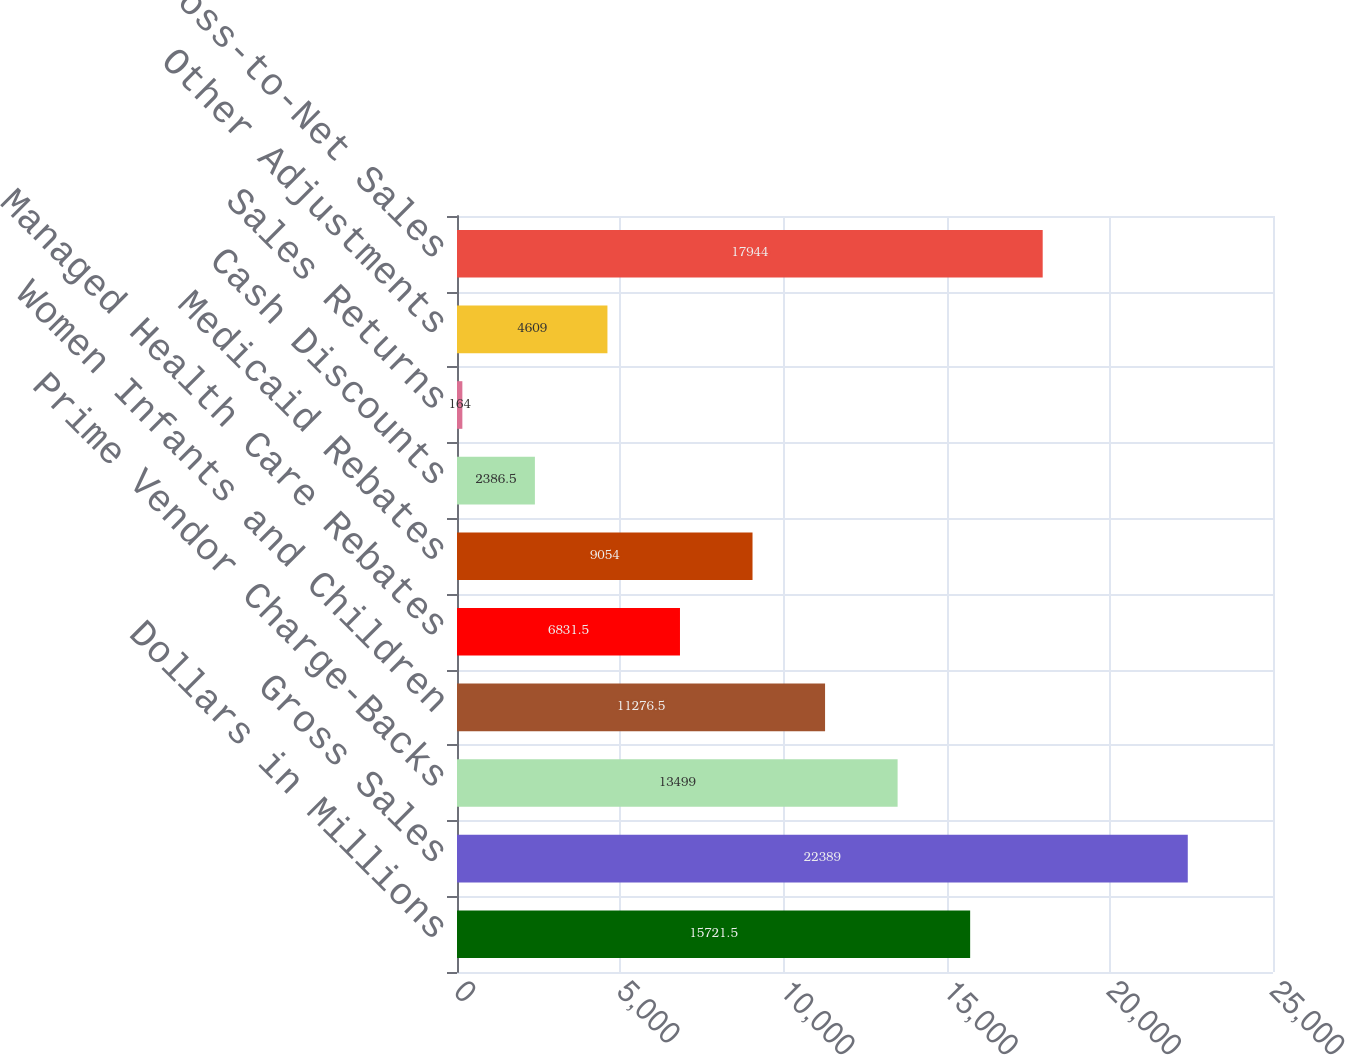Convert chart. <chart><loc_0><loc_0><loc_500><loc_500><bar_chart><fcel>Dollars in Millions<fcel>Gross Sales<fcel>Prime Vendor Charge-Backs<fcel>Women Infants and Children<fcel>Managed Health Care Rebates<fcel>Medicaid Rebates<fcel>Cash Discounts<fcel>Sales Returns<fcel>Other Adjustments<fcel>Total Gross-to-Net Sales<nl><fcel>15721.5<fcel>22389<fcel>13499<fcel>11276.5<fcel>6831.5<fcel>9054<fcel>2386.5<fcel>164<fcel>4609<fcel>17944<nl></chart> 